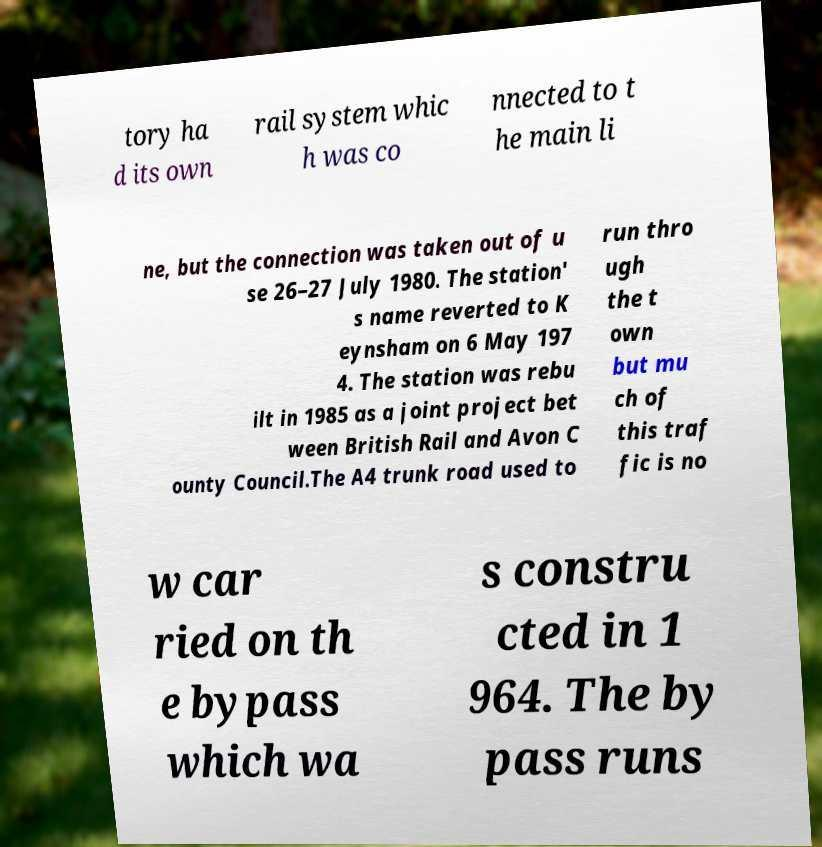For documentation purposes, I need the text within this image transcribed. Could you provide that? tory ha d its own rail system whic h was co nnected to t he main li ne, but the connection was taken out of u se 26–27 July 1980. The station' s name reverted to K eynsham on 6 May 197 4. The station was rebu ilt in 1985 as a joint project bet ween British Rail and Avon C ounty Council.The A4 trunk road used to run thro ugh the t own but mu ch of this traf fic is no w car ried on th e bypass which wa s constru cted in 1 964. The by pass runs 